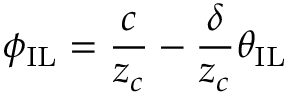Convert formula to latex. <formula><loc_0><loc_0><loc_500><loc_500>\phi _ { I L } = \frac { c } { z _ { c } } - \frac { \delta } { z _ { c } } \theta _ { I L }</formula> 